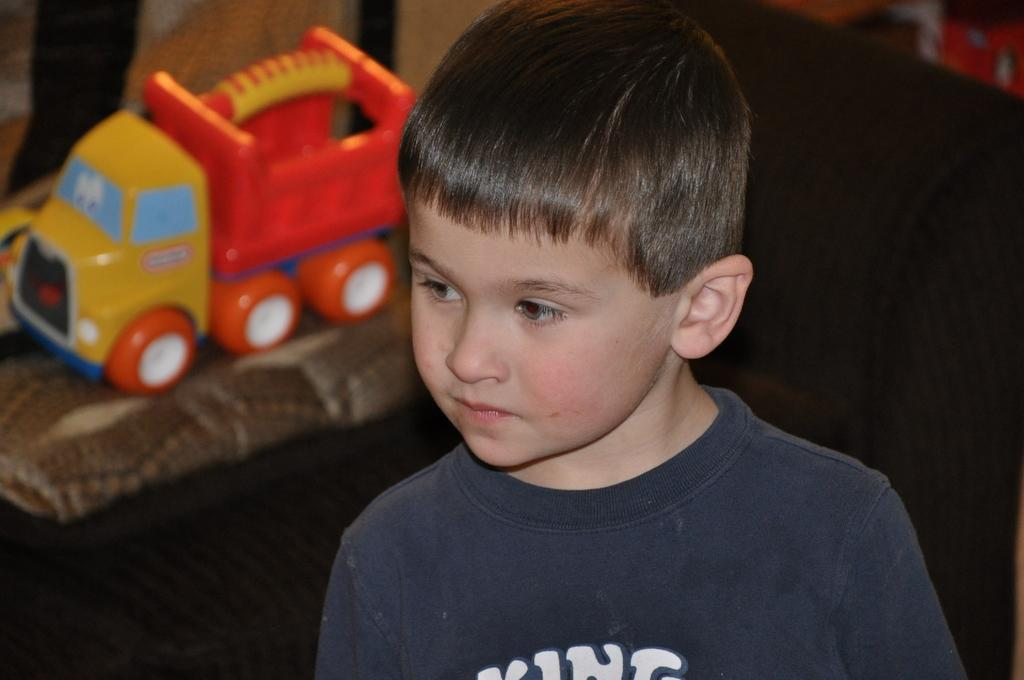Who is the main subject in the image? There is a boy in the image. What can be seen behind the boy? Toys are present on a cloth behind the boy. What is visible at the bottom of the image? The floor is visible at the bottom of the image. Where are more toys located in the image? There are additional toys on the right side of the image. What type of verse is being recited by the boy in the image? There is no indication in the image that the boy is reciting a verse, so it cannot be determined from the picture. 